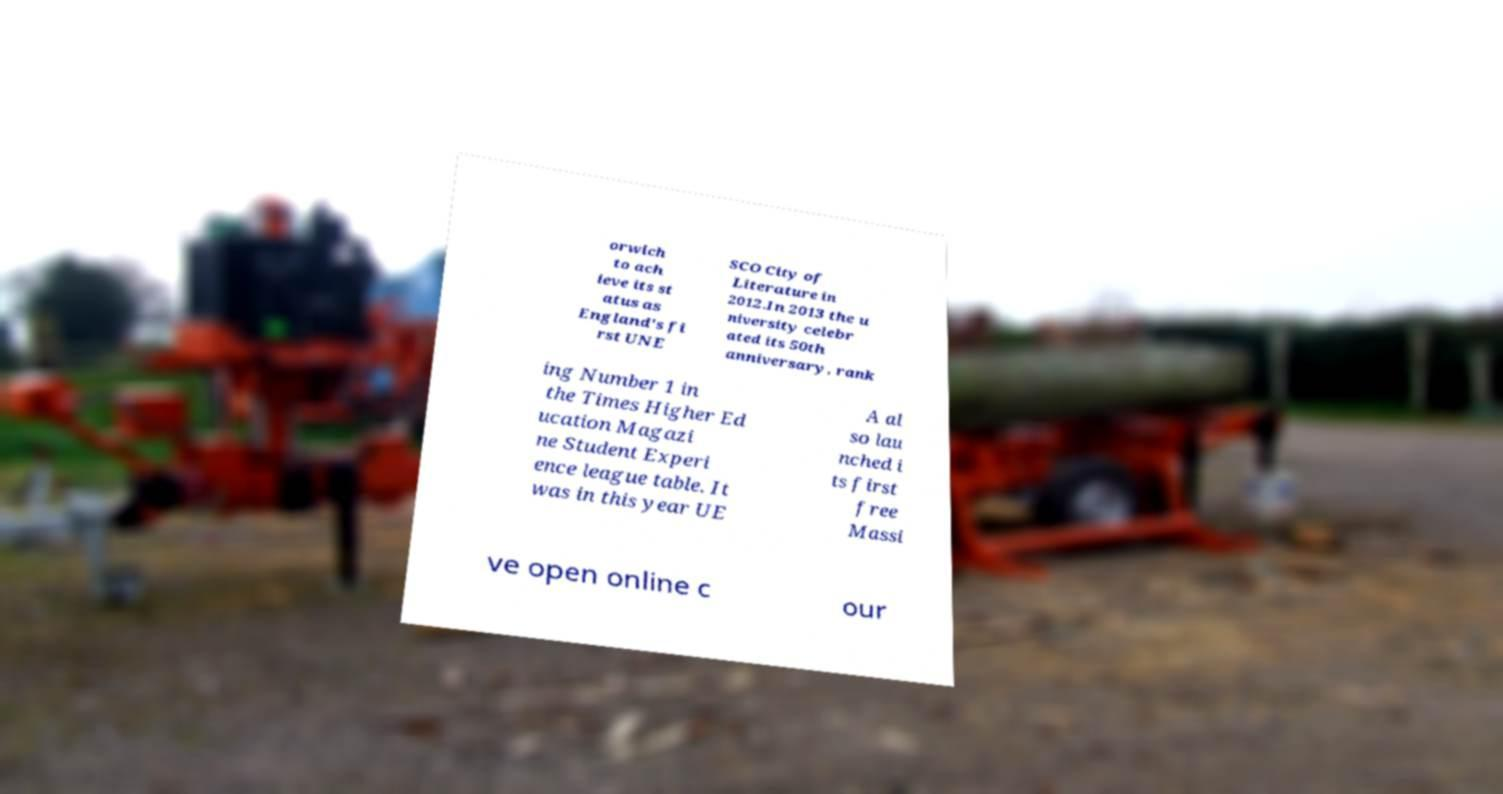Please identify and transcribe the text found in this image. orwich to ach ieve its st atus as England's fi rst UNE SCO City of Literature in 2012.In 2013 the u niversity celebr ated its 50th anniversary, rank ing Number 1 in the Times Higher Ed ucation Magazi ne Student Experi ence league table. It was in this year UE A al so lau nched i ts first free Massi ve open online c our 